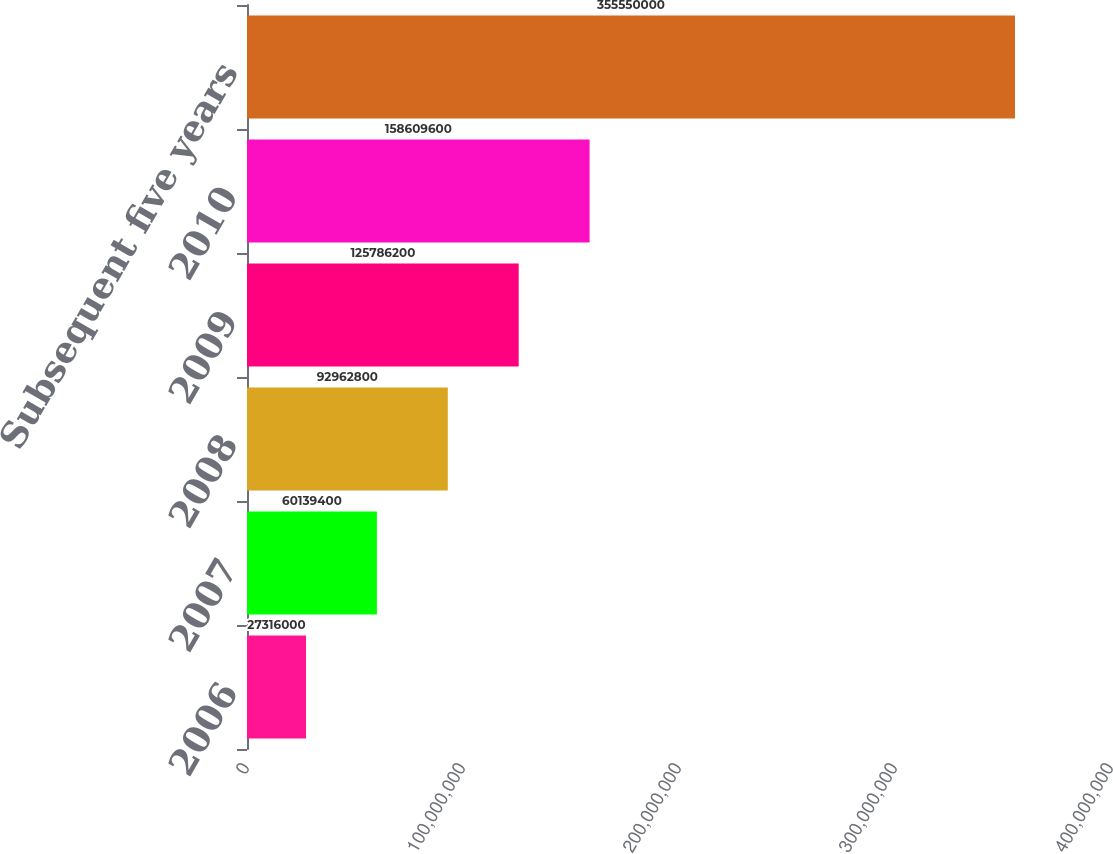<chart> <loc_0><loc_0><loc_500><loc_500><bar_chart><fcel>2006<fcel>2007<fcel>2008<fcel>2009<fcel>2010<fcel>Subsequent five years<nl><fcel>2.7316e+07<fcel>6.01394e+07<fcel>9.29628e+07<fcel>1.25786e+08<fcel>1.5861e+08<fcel>3.5555e+08<nl></chart> 